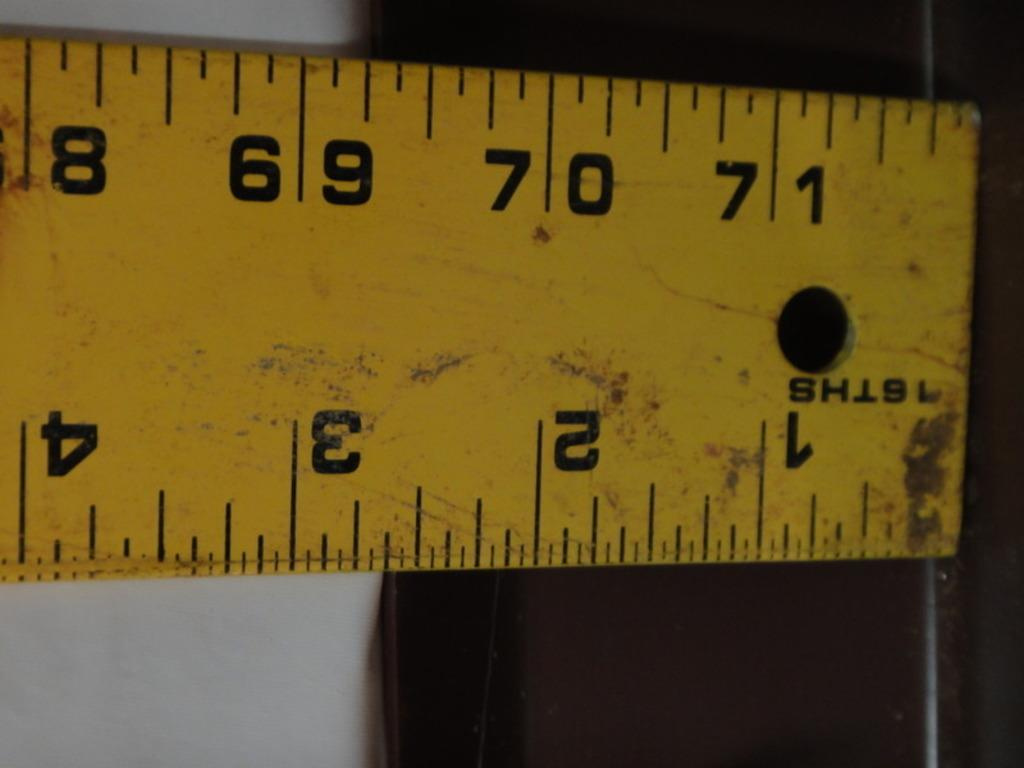<image>
Offer a succinct explanation of the picture presented. A close up of a ruler that has a hole punched towards the end and an ID of 16THS. 